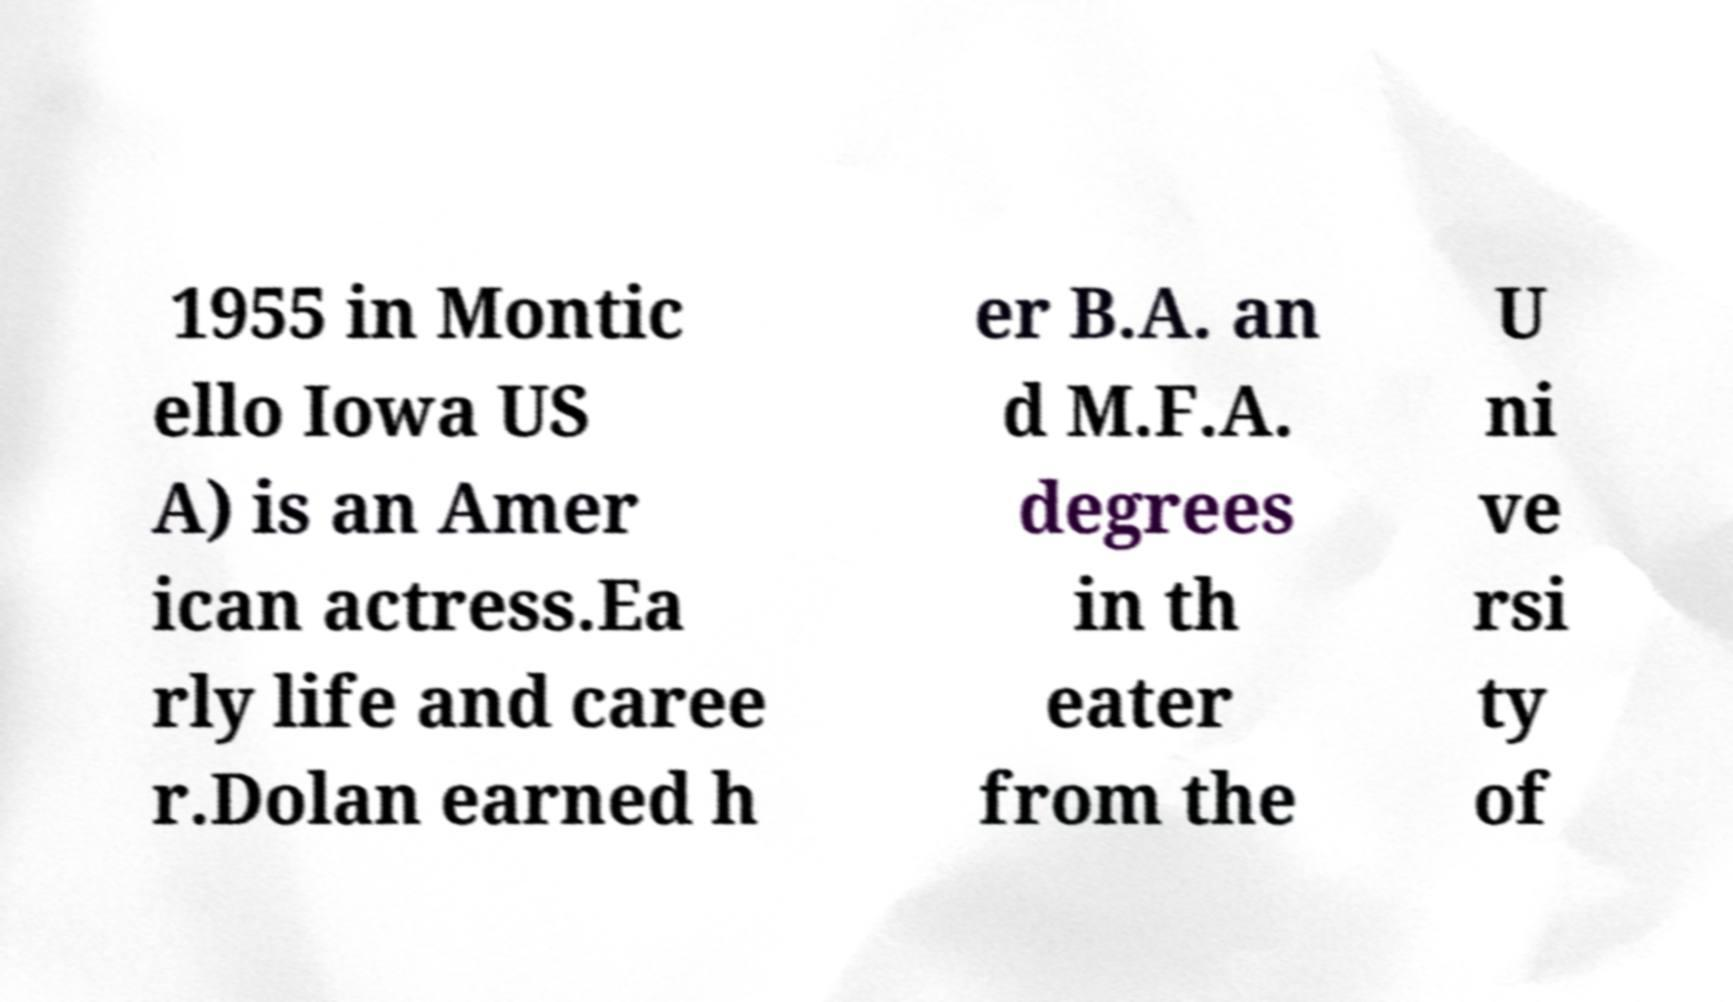There's text embedded in this image that I need extracted. Can you transcribe it verbatim? 1955 in Montic ello Iowa US A) is an Amer ican actress.Ea rly life and caree r.Dolan earned h er B.A. an d M.F.A. degrees in th eater from the U ni ve rsi ty of 